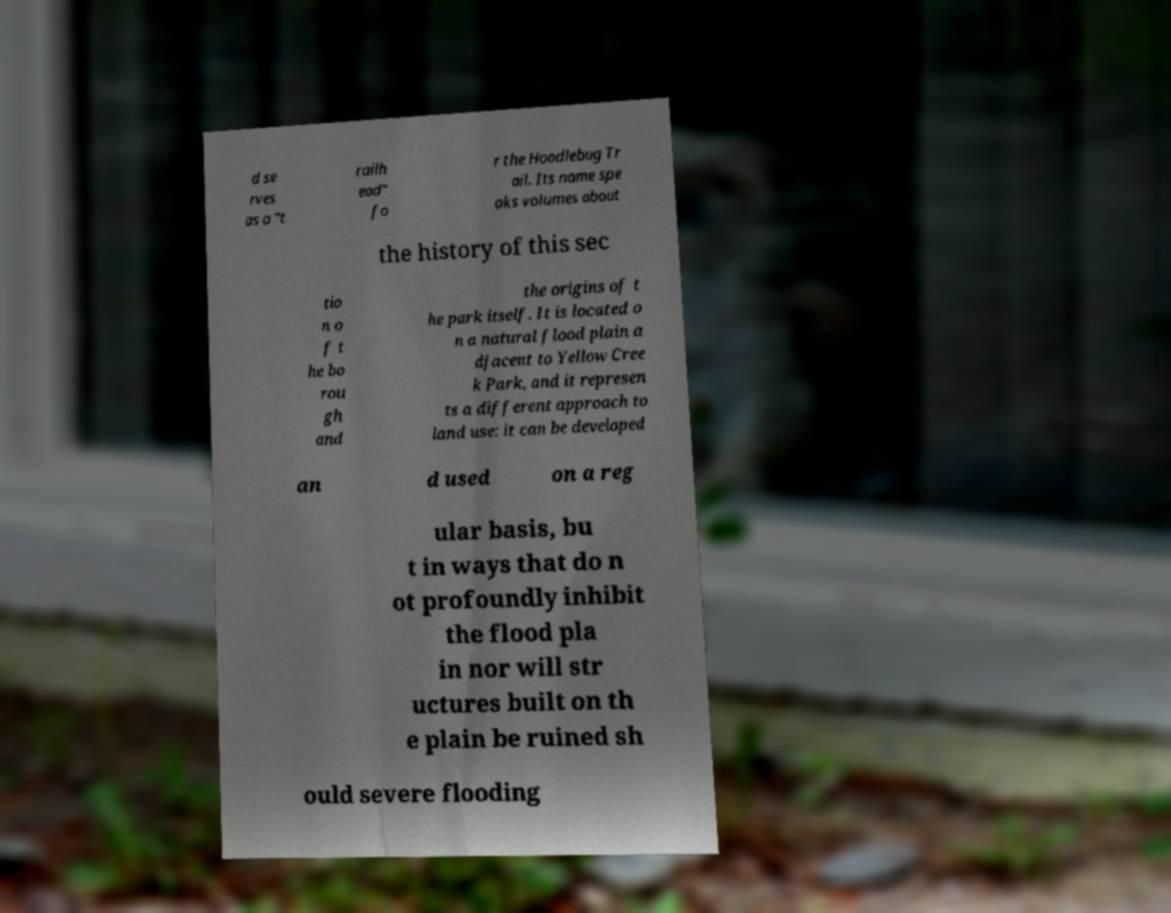Could you assist in decoding the text presented in this image and type it out clearly? d se rves as a "t railh ead" fo r the Hoodlebug Tr ail. Its name spe aks volumes about the history of this sec tio n o f t he bo rou gh and the origins of t he park itself. It is located o n a natural flood plain a djacent to Yellow Cree k Park, and it represen ts a different approach to land use: it can be developed an d used on a reg ular basis, bu t in ways that do n ot profoundly inhibit the flood pla in nor will str uctures built on th e plain be ruined sh ould severe flooding 